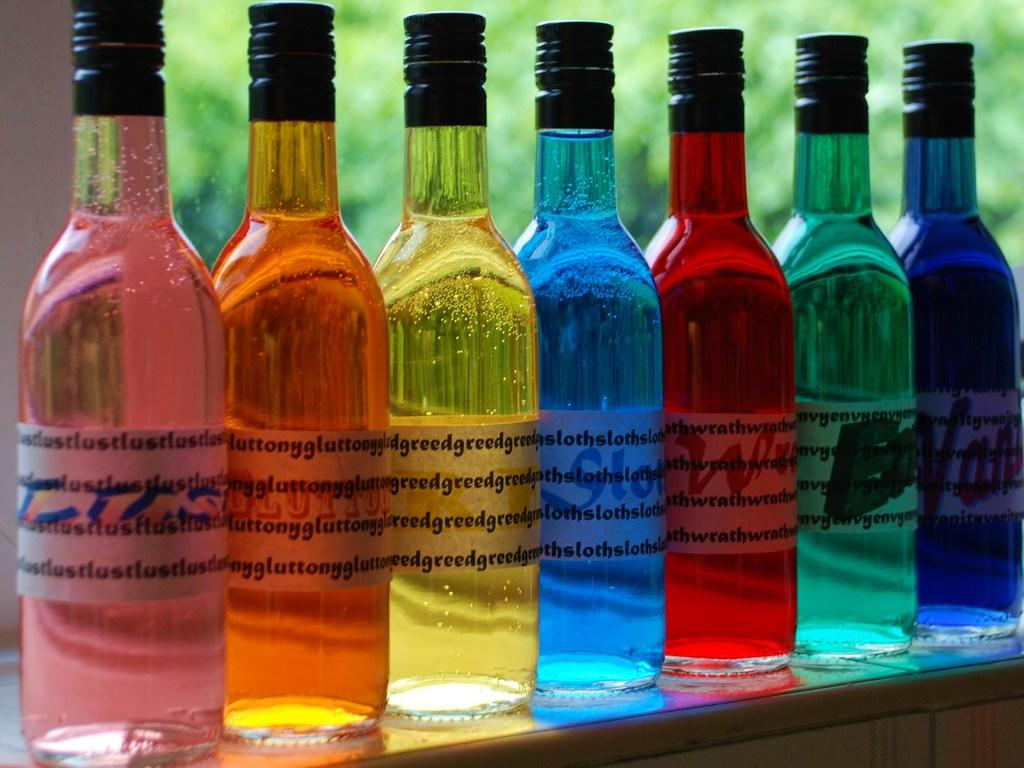<image>
Offer a succinct explanation of the picture presented. a row of different colored bottles on a counter that say 'greed' on the labels 